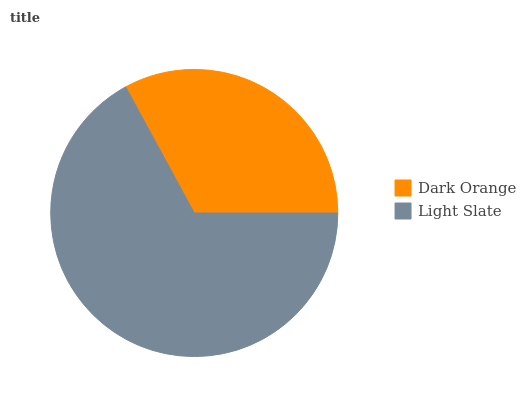Is Dark Orange the minimum?
Answer yes or no. Yes. Is Light Slate the maximum?
Answer yes or no. Yes. Is Light Slate the minimum?
Answer yes or no. No. Is Light Slate greater than Dark Orange?
Answer yes or no. Yes. Is Dark Orange less than Light Slate?
Answer yes or no. Yes. Is Dark Orange greater than Light Slate?
Answer yes or no. No. Is Light Slate less than Dark Orange?
Answer yes or no. No. Is Light Slate the high median?
Answer yes or no. Yes. Is Dark Orange the low median?
Answer yes or no. Yes. Is Dark Orange the high median?
Answer yes or no. No. Is Light Slate the low median?
Answer yes or no. No. 